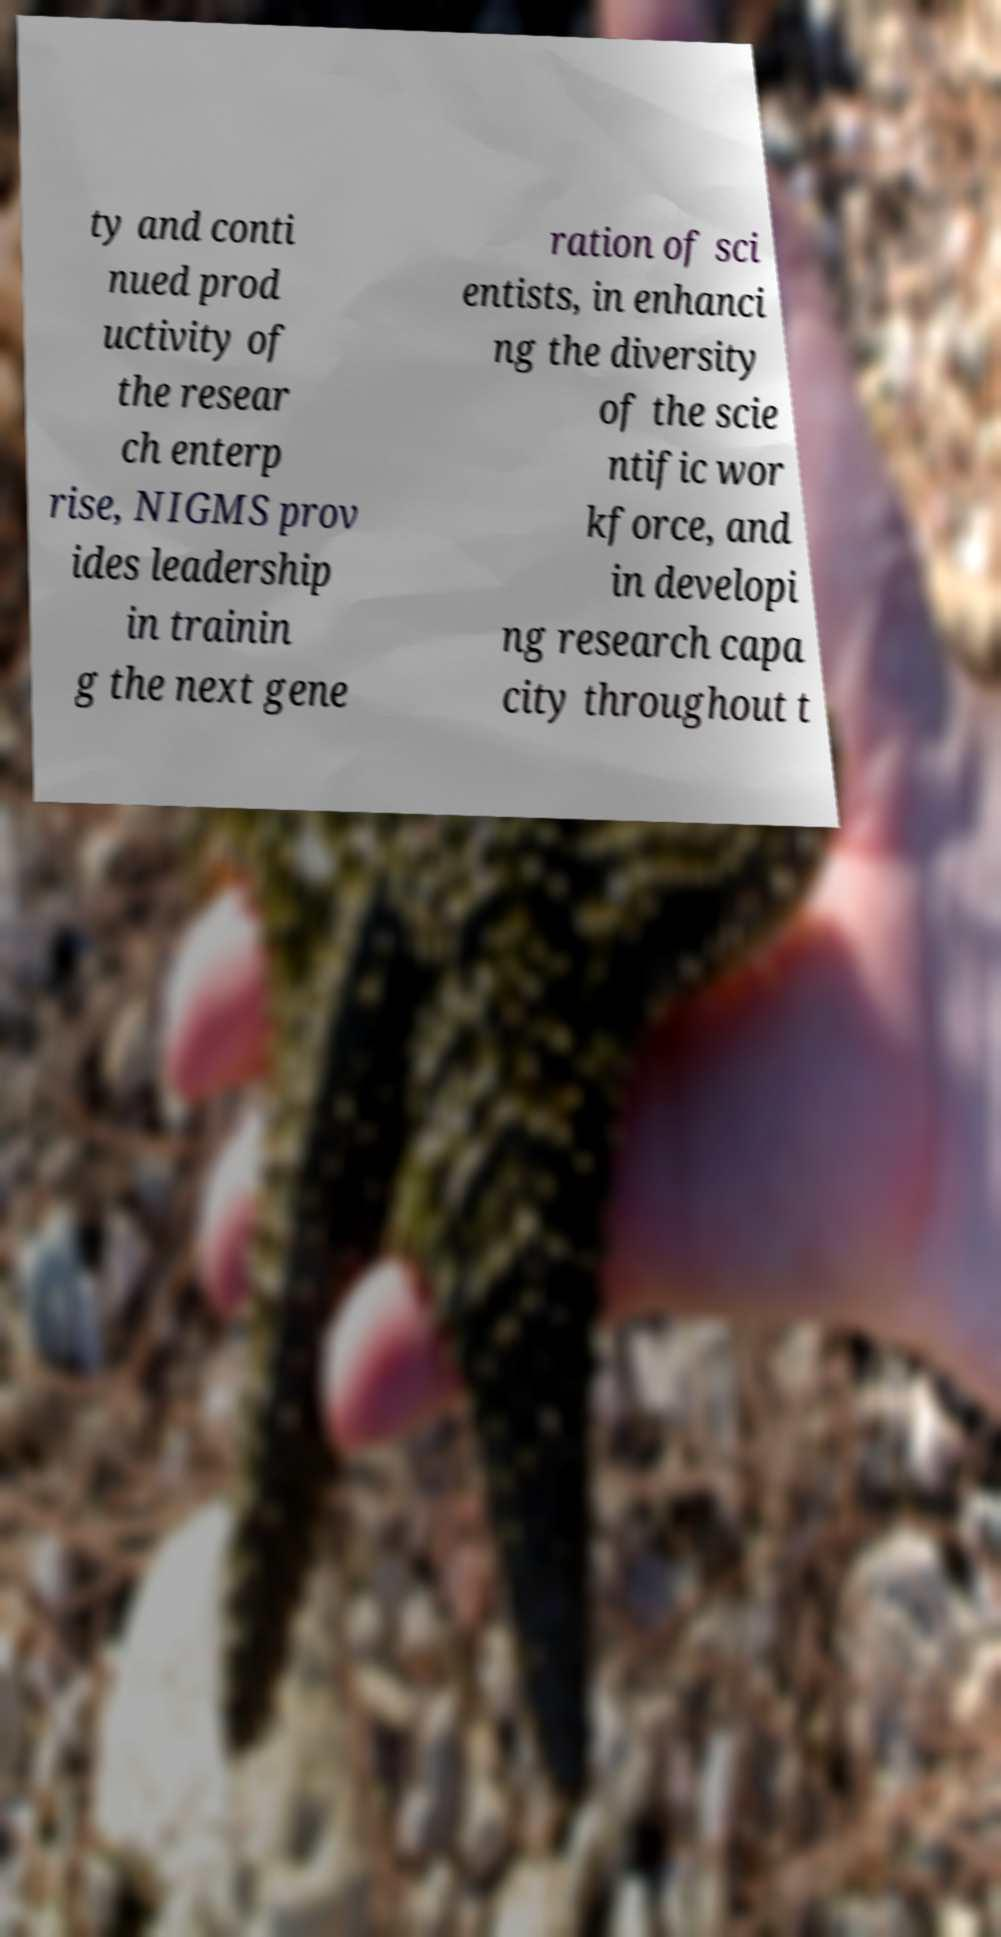Can you read and provide the text displayed in the image?This photo seems to have some interesting text. Can you extract and type it out for me? ty and conti nued prod uctivity of the resear ch enterp rise, NIGMS prov ides leadership in trainin g the next gene ration of sci entists, in enhanci ng the diversity of the scie ntific wor kforce, and in developi ng research capa city throughout t 